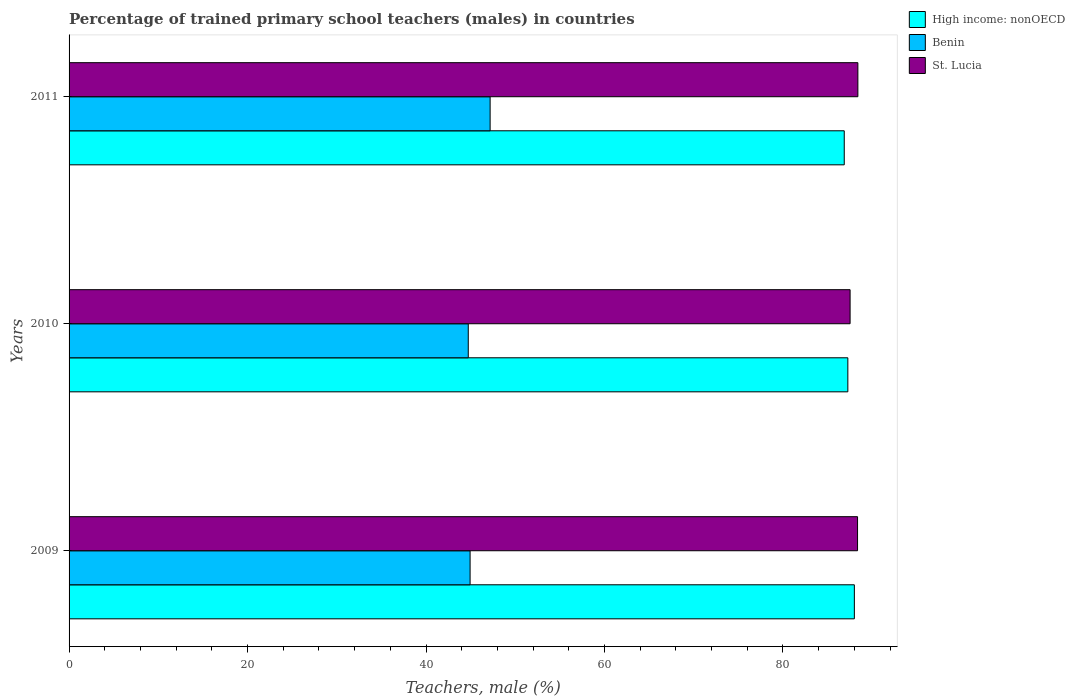How many different coloured bars are there?
Give a very brief answer. 3. How many groups of bars are there?
Give a very brief answer. 3. How many bars are there on the 2nd tick from the top?
Keep it short and to the point. 3. What is the percentage of trained primary school teachers (males) in Benin in 2011?
Make the answer very short. 47.19. Across all years, what is the maximum percentage of trained primary school teachers (males) in Benin?
Provide a short and direct response. 47.19. Across all years, what is the minimum percentage of trained primary school teachers (males) in Benin?
Offer a terse response. 44.74. In which year was the percentage of trained primary school teachers (males) in Benin minimum?
Make the answer very short. 2010. What is the total percentage of trained primary school teachers (males) in Benin in the graph?
Your response must be concise. 136.86. What is the difference between the percentage of trained primary school teachers (males) in St. Lucia in 2010 and that in 2011?
Keep it short and to the point. -0.87. What is the difference between the percentage of trained primary school teachers (males) in St. Lucia in 2010 and the percentage of trained primary school teachers (males) in Benin in 2009?
Keep it short and to the point. 42.59. What is the average percentage of trained primary school teachers (males) in St. Lucia per year?
Make the answer very short. 88.1. In the year 2011, what is the difference between the percentage of trained primary school teachers (males) in High income: nonOECD and percentage of trained primary school teachers (males) in Benin?
Provide a short and direct response. 39.69. In how many years, is the percentage of trained primary school teachers (males) in High income: nonOECD greater than 24 %?
Provide a succinct answer. 3. What is the ratio of the percentage of trained primary school teachers (males) in Benin in 2009 to that in 2011?
Keep it short and to the point. 0.95. Is the percentage of trained primary school teachers (males) in St. Lucia in 2010 less than that in 2011?
Your response must be concise. Yes. What is the difference between the highest and the second highest percentage of trained primary school teachers (males) in St. Lucia?
Keep it short and to the point. 0.04. What is the difference between the highest and the lowest percentage of trained primary school teachers (males) in St. Lucia?
Your answer should be very brief. 0.87. In how many years, is the percentage of trained primary school teachers (males) in Benin greater than the average percentage of trained primary school teachers (males) in Benin taken over all years?
Your response must be concise. 1. Is the sum of the percentage of trained primary school teachers (males) in St. Lucia in 2010 and 2011 greater than the maximum percentage of trained primary school teachers (males) in High income: nonOECD across all years?
Ensure brevity in your answer.  Yes. What does the 2nd bar from the top in 2011 represents?
Provide a succinct answer. Benin. What does the 1st bar from the bottom in 2009 represents?
Your response must be concise. High income: nonOECD. Is it the case that in every year, the sum of the percentage of trained primary school teachers (males) in St. Lucia and percentage of trained primary school teachers (males) in Benin is greater than the percentage of trained primary school teachers (males) in High income: nonOECD?
Make the answer very short. Yes. Are all the bars in the graph horizontal?
Provide a short and direct response. Yes. Does the graph contain any zero values?
Give a very brief answer. No. Does the graph contain grids?
Provide a short and direct response. No. What is the title of the graph?
Provide a succinct answer. Percentage of trained primary school teachers (males) in countries. What is the label or title of the X-axis?
Make the answer very short. Teachers, male (%). What is the label or title of the Y-axis?
Your answer should be compact. Years. What is the Teachers, male (%) of High income: nonOECD in 2009?
Your response must be concise. 88.01. What is the Teachers, male (%) of Benin in 2009?
Offer a very short reply. 44.94. What is the Teachers, male (%) in St. Lucia in 2009?
Provide a succinct answer. 88.36. What is the Teachers, male (%) of High income: nonOECD in 2010?
Keep it short and to the point. 87.27. What is the Teachers, male (%) in Benin in 2010?
Ensure brevity in your answer.  44.74. What is the Teachers, male (%) of St. Lucia in 2010?
Your response must be concise. 87.53. What is the Teachers, male (%) of High income: nonOECD in 2011?
Give a very brief answer. 86.87. What is the Teachers, male (%) in Benin in 2011?
Your answer should be compact. 47.19. What is the Teachers, male (%) of St. Lucia in 2011?
Keep it short and to the point. 88.4. Across all years, what is the maximum Teachers, male (%) of High income: nonOECD?
Provide a short and direct response. 88.01. Across all years, what is the maximum Teachers, male (%) of Benin?
Ensure brevity in your answer.  47.19. Across all years, what is the maximum Teachers, male (%) in St. Lucia?
Your answer should be very brief. 88.4. Across all years, what is the minimum Teachers, male (%) of High income: nonOECD?
Ensure brevity in your answer.  86.87. Across all years, what is the minimum Teachers, male (%) in Benin?
Provide a short and direct response. 44.74. Across all years, what is the minimum Teachers, male (%) in St. Lucia?
Provide a succinct answer. 87.53. What is the total Teachers, male (%) of High income: nonOECD in the graph?
Your answer should be compact. 262.15. What is the total Teachers, male (%) in Benin in the graph?
Offer a very short reply. 136.86. What is the total Teachers, male (%) of St. Lucia in the graph?
Your response must be concise. 264.29. What is the difference between the Teachers, male (%) of High income: nonOECD in 2009 and that in 2010?
Give a very brief answer. 0.73. What is the difference between the Teachers, male (%) of Benin in 2009 and that in 2010?
Offer a terse response. 0.21. What is the difference between the Teachers, male (%) of St. Lucia in 2009 and that in 2010?
Provide a short and direct response. 0.83. What is the difference between the Teachers, male (%) of High income: nonOECD in 2009 and that in 2011?
Offer a terse response. 1.13. What is the difference between the Teachers, male (%) of Benin in 2009 and that in 2011?
Your response must be concise. -2.24. What is the difference between the Teachers, male (%) in St. Lucia in 2009 and that in 2011?
Offer a terse response. -0.04. What is the difference between the Teachers, male (%) of High income: nonOECD in 2010 and that in 2011?
Provide a short and direct response. 0.4. What is the difference between the Teachers, male (%) of Benin in 2010 and that in 2011?
Provide a succinct answer. -2.45. What is the difference between the Teachers, male (%) of St. Lucia in 2010 and that in 2011?
Your answer should be very brief. -0.87. What is the difference between the Teachers, male (%) in High income: nonOECD in 2009 and the Teachers, male (%) in Benin in 2010?
Provide a short and direct response. 43.27. What is the difference between the Teachers, male (%) in High income: nonOECD in 2009 and the Teachers, male (%) in St. Lucia in 2010?
Your response must be concise. 0.48. What is the difference between the Teachers, male (%) of Benin in 2009 and the Teachers, male (%) of St. Lucia in 2010?
Your response must be concise. -42.59. What is the difference between the Teachers, male (%) of High income: nonOECD in 2009 and the Teachers, male (%) of Benin in 2011?
Offer a terse response. 40.82. What is the difference between the Teachers, male (%) of High income: nonOECD in 2009 and the Teachers, male (%) of St. Lucia in 2011?
Keep it short and to the point. -0.39. What is the difference between the Teachers, male (%) of Benin in 2009 and the Teachers, male (%) of St. Lucia in 2011?
Offer a terse response. -43.46. What is the difference between the Teachers, male (%) in High income: nonOECD in 2010 and the Teachers, male (%) in Benin in 2011?
Provide a succinct answer. 40.09. What is the difference between the Teachers, male (%) of High income: nonOECD in 2010 and the Teachers, male (%) of St. Lucia in 2011?
Your response must be concise. -1.13. What is the difference between the Teachers, male (%) in Benin in 2010 and the Teachers, male (%) in St. Lucia in 2011?
Give a very brief answer. -43.66. What is the average Teachers, male (%) in High income: nonOECD per year?
Keep it short and to the point. 87.38. What is the average Teachers, male (%) of Benin per year?
Ensure brevity in your answer.  45.62. What is the average Teachers, male (%) in St. Lucia per year?
Provide a succinct answer. 88.1. In the year 2009, what is the difference between the Teachers, male (%) of High income: nonOECD and Teachers, male (%) of Benin?
Offer a terse response. 43.06. In the year 2009, what is the difference between the Teachers, male (%) of High income: nonOECD and Teachers, male (%) of St. Lucia?
Offer a very short reply. -0.36. In the year 2009, what is the difference between the Teachers, male (%) in Benin and Teachers, male (%) in St. Lucia?
Offer a very short reply. -43.42. In the year 2010, what is the difference between the Teachers, male (%) of High income: nonOECD and Teachers, male (%) of Benin?
Make the answer very short. 42.54. In the year 2010, what is the difference between the Teachers, male (%) of High income: nonOECD and Teachers, male (%) of St. Lucia?
Make the answer very short. -0.25. In the year 2010, what is the difference between the Teachers, male (%) in Benin and Teachers, male (%) in St. Lucia?
Provide a succinct answer. -42.79. In the year 2011, what is the difference between the Teachers, male (%) of High income: nonOECD and Teachers, male (%) of Benin?
Provide a succinct answer. 39.69. In the year 2011, what is the difference between the Teachers, male (%) of High income: nonOECD and Teachers, male (%) of St. Lucia?
Your answer should be very brief. -1.53. In the year 2011, what is the difference between the Teachers, male (%) of Benin and Teachers, male (%) of St. Lucia?
Ensure brevity in your answer.  -41.21. What is the ratio of the Teachers, male (%) of High income: nonOECD in 2009 to that in 2010?
Give a very brief answer. 1.01. What is the ratio of the Teachers, male (%) of Benin in 2009 to that in 2010?
Provide a succinct answer. 1. What is the ratio of the Teachers, male (%) of St. Lucia in 2009 to that in 2010?
Ensure brevity in your answer.  1.01. What is the ratio of the Teachers, male (%) in High income: nonOECD in 2009 to that in 2011?
Offer a very short reply. 1.01. What is the ratio of the Teachers, male (%) of Benin in 2009 to that in 2011?
Provide a succinct answer. 0.95. What is the ratio of the Teachers, male (%) in High income: nonOECD in 2010 to that in 2011?
Offer a very short reply. 1. What is the ratio of the Teachers, male (%) in Benin in 2010 to that in 2011?
Offer a terse response. 0.95. What is the difference between the highest and the second highest Teachers, male (%) of High income: nonOECD?
Make the answer very short. 0.73. What is the difference between the highest and the second highest Teachers, male (%) in Benin?
Make the answer very short. 2.24. What is the difference between the highest and the second highest Teachers, male (%) of St. Lucia?
Make the answer very short. 0.04. What is the difference between the highest and the lowest Teachers, male (%) in High income: nonOECD?
Give a very brief answer. 1.13. What is the difference between the highest and the lowest Teachers, male (%) of Benin?
Your answer should be compact. 2.45. What is the difference between the highest and the lowest Teachers, male (%) in St. Lucia?
Your answer should be very brief. 0.87. 